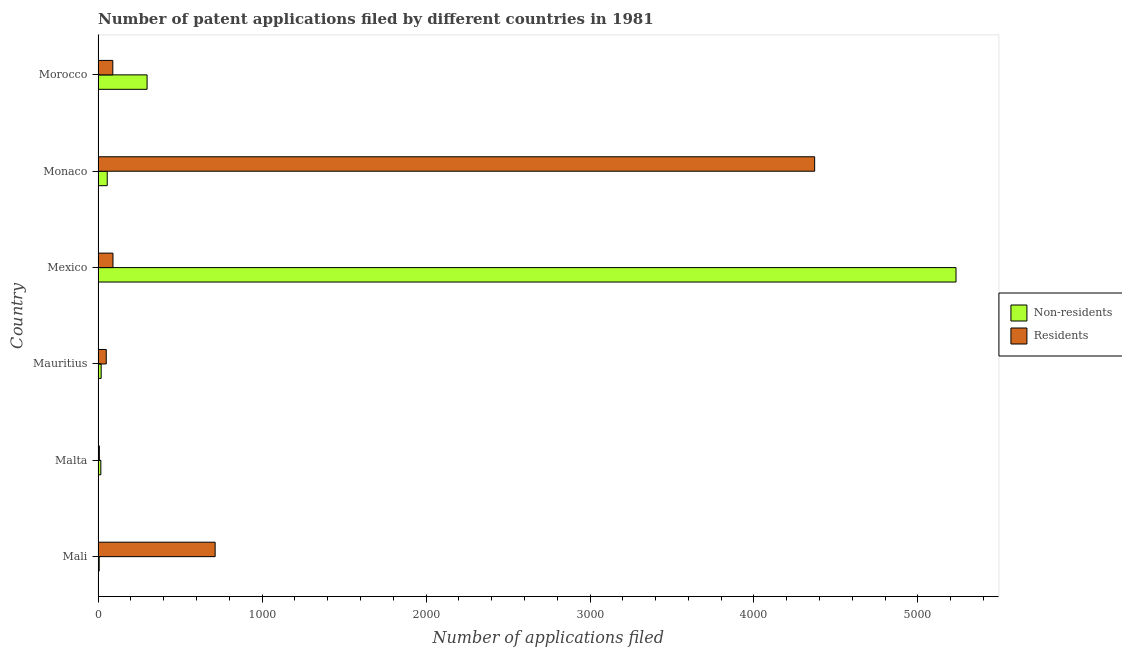How many different coloured bars are there?
Provide a succinct answer. 2. Are the number of bars per tick equal to the number of legend labels?
Offer a terse response. Yes. Are the number of bars on each tick of the Y-axis equal?
Your answer should be very brief. Yes. How many bars are there on the 2nd tick from the top?
Offer a terse response. 2. What is the label of the 1st group of bars from the top?
Offer a very short reply. Morocco. In how many cases, is the number of bars for a given country not equal to the number of legend labels?
Your response must be concise. 0. What is the number of patent applications by non residents in Mali?
Offer a terse response. 7. Across all countries, what is the maximum number of patent applications by non residents?
Your answer should be very brief. 5232. Across all countries, what is the minimum number of patent applications by residents?
Your answer should be compact. 8. In which country was the number of patent applications by residents minimum?
Make the answer very short. Malta. What is the total number of patent applications by residents in the graph?
Keep it short and to the point. 5323. What is the difference between the number of patent applications by residents in Mali and that in Monaco?
Offer a very short reply. -3656. What is the difference between the number of patent applications by residents in Mali and the number of patent applications by non residents in Monaco?
Ensure brevity in your answer.  658. What is the average number of patent applications by residents per country?
Provide a succinct answer. 887.17. What is the difference between the number of patent applications by non residents and number of patent applications by residents in Mexico?
Your answer should be very brief. 5141. What is the ratio of the number of patent applications by non residents in Malta to that in Morocco?
Ensure brevity in your answer.  0.06. Is the number of patent applications by non residents in Mexico less than that in Monaco?
Keep it short and to the point. No. Is the difference between the number of patent applications by residents in Malta and Mauritius greater than the difference between the number of patent applications by non residents in Malta and Mauritius?
Keep it short and to the point. No. What is the difference between the highest and the second highest number of patent applications by residents?
Keep it short and to the point. 3656. What is the difference between the highest and the lowest number of patent applications by residents?
Make the answer very short. 4362. Is the sum of the number of patent applications by residents in Malta and Monaco greater than the maximum number of patent applications by non residents across all countries?
Provide a succinct answer. No. What does the 2nd bar from the top in Mexico represents?
Provide a short and direct response. Non-residents. What does the 2nd bar from the bottom in Malta represents?
Offer a terse response. Residents. How many bars are there?
Ensure brevity in your answer.  12. Are all the bars in the graph horizontal?
Make the answer very short. Yes. What is the difference between two consecutive major ticks on the X-axis?
Ensure brevity in your answer.  1000. Are the values on the major ticks of X-axis written in scientific E-notation?
Keep it short and to the point. No. Does the graph contain any zero values?
Your answer should be very brief. No. Does the graph contain grids?
Offer a terse response. No. Where does the legend appear in the graph?
Your answer should be very brief. Center right. How many legend labels are there?
Provide a short and direct response. 2. What is the title of the graph?
Offer a very short reply. Number of patent applications filed by different countries in 1981. What is the label or title of the X-axis?
Offer a terse response. Number of applications filed. What is the label or title of the Y-axis?
Make the answer very short. Country. What is the Number of applications filed of Residents in Mali?
Your response must be concise. 714. What is the Number of applications filed in Non-residents in Malta?
Ensure brevity in your answer.  17. What is the Number of applications filed in Residents in Malta?
Your response must be concise. 8. What is the Number of applications filed of Residents in Mauritius?
Offer a terse response. 50. What is the Number of applications filed in Non-residents in Mexico?
Make the answer very short. 5232. What is the Number of applications filed in Residents in Mexico?
Provide a succinct answer. 91. What is the Number of applications filed of Non-residents in Monaco?
Offer a very short reply. 56. What is the Number of applications filed of Residents in Monaco?
Your answer should be compact. 4370. What is the Number of applications filed of Non-residents in Morocco?
Offer a terse response. 299. What is the Number of applications filed in Residents in Morocco?
Your response must be concise. 90. Across all countries, what is the maximum Number of applications filed of Non-residents?
Give a very brief answer. 5232. Across all countries, what is the maximum Number of applications filed of Residents?
Ensure brevity in your answer.  4370. What is the total Number of applications filed of Non-residents in the graph?
Provide a succinct answer. 5630. What is the total Number of applications filed in Residents in the graph?
Your answer should be very brief. 5323. What is the difference between the Number of applications filed of Residents in Mali and that in Malta?
Ensure brevity in your answer.  706. What is the difference between the Number of applications filed in Non-residents in Mali and that in Mauritius?
Make the answer very short. -12. What is the difference between the Number of applications filed of Residents in Mali and that in Mauritius?
Offer a terse response. 664. What is the difference between the Number of applications filed of Non-residents in Mali and that in Mexico?
Your answer should be compact. -5225. What is the difference between the Number of applications filed in Residents in Mali and that in Mexico?
Keep it short and to the point. 623. What is the difference between the Number of applications filed of Non-residents in Mali and that in Monaco?
Give a very brief answer. -49. What is the difference between the Number of applications filed of Residents in Mali and that in Monaco?
Your answer should be very brief. -3656. What is the difference between the Number of applications filed of Non-residents in Mali and that in Morocco?
Make the answer very short. -292. What is the difference between the Number of applications filed of Residents in Mali and that in Morocco?
Give a very brief answer. 624. What is the difference between the Number of applications filed in Residents in Malta and that in Mauritius?
Offer a terse response. -42. What is the difference between the Number of applications filed in Non-residents in Malta and that in Mexico?
Offer a terse response. -5215. What is the difference between the Number of applications filed of Residents in Malta and that in Mexico?
Your answer should be very brief. -83. What is the difference between the Number of applications filed in Non-residents in Malta and that in Monaco?
Your response must be concise. -39. What is the difference between the Number of applications filed of Residents in Malta and that in Monaco?
Offer a very short reply. -4362. What is the difference between the Number of applications filed of Non-residents in Malta and that in Morocco?
Ensure brevity in your answer.  -282. What is the difference between the Number of applications filed in Residents in Malta and that in Morocco?
Offer a terse response. -82. What is the difference between the Number of applications filed of Non-residents in Mauritius and that in Mexico?
Keep it short and to the point. -5213. What is the difference between the Number of applications filed in Residents in Mauritius and that in Mexico?
Offer a very short reply. -41. What is the difference between the Number of applications filed of Non-residents in Mauritius and that in Monaco?
Ensure brevity in your answer.  -37. What is the difference between the Number of applications filed in Residents in Mauritius and that in Monaco?
Your answer should be compact. -4320. What is the difference between the Number of applications filed in Non-residents in Mauritius and that in Morocco?
Your answer should be very brief. -280. What is the difference between the Number of applications filed of Residents in Mauritius and that in Morocco?
Ensure brevity in your answer.  -40. What is the difference between the Number of applications filed in Non-residents in Mexico and that in Monaco?
Ensure brevity in your answer.  5176. What is the difference between the Number of applications filed of Residents in Mexico and that in Monaco?
Provide a short and direct response. -4279. What is the difference between the Number of applications filed in Non-residents in Mexico and that in Morocco?
Make the answer very short. 4933. What is the difference between the Number of applications filed of Non-residents in Monaco and that in Morocco?
Offer a terse response. -243. What is the difference between the Number of applications filed in Residents in Monaco and that in Morocco?
Ensure brevity in your answer.  4280. What is the difference between the Number of applications filed in Non-residents in Mali and the Number of applications filed in Residents in Malta?
Provide a succinct answer. -1. What is the difference between the Number of applications filed of Non-residents in Mali and the Number of applications filed of Residents in Mauritius?
Provide a succinct answer. -43. What is the difference between the Number of applications filed of Non-residents in Mali and the Number of applications filed of Residents in Mexico?
Give a very brief answer. -84. What is the difference between the Number of applications filed of Non-residents in Mali and the Number of applications filed of Residents in Monaco?
Ensure brevity in your answer.  -4363. What is the difference between the Number of applications filed in Non-residents in Mali and the Number of applications filed in Residents in Morocco?
Offer a terse response. -83. What is the difference between the Number of applications filed in Non-residents in Malta and the Number of applications filed in Residents in Mauritius?
Offer a terse response. -33. What is the difference between the Number of applications filed of Non-residents in Malta and the Number of applications filed of Residents in Mexico?
Your answer should be very brief. -74. What is the difference between the Number of applications filed of Non-residents in Malta and the Number of applications filed of Residents in Monaco?
Offer a terse response. -4353. What is the difference between the Number of applications filed of Non-residents in Malta and the Number of applications filed of Residents in Morocco?
Provide a succinct answer. -73. What is the difference between the Number of applications filed in Non-residents in Mauritius and the Number of applications filed in Residents in Mexico?
Give a very brief answer. -72. What is the difference between the Number of applications filed of Non-residents in Mauritius and the Number of applications filed of Residents in Monaco?
Offer a very short reply. -4351. What is the difference between the Number of applications filed in Non-residents in Mauritius and the Number of applications filed in Residents in Morocco?
Your answer should be very brief. -71. What is the difference between the Number of applications filed of Non-residents in Mexico and the Number of applications filed of Residents in Monaco?
Offer a very short reply. 862. What is the difference between the Number of applications filed in Non-residents in Mexico and the Number of applications filed in Residents in Morocco?
Give a very brief answer. 5142. What is the difference between the Number of applications filed in Non-residents in Monaco and the Number of applications filed in Residents in Morocco?
Offer a very short reply. -34. What is the average Number of applications filed in Non-residents per country?
Provide a succinct answer. 938.33. What is the average Number of applications filed in Residents per country?
Provide a succinct answer. 887.17. What is the difference between the Number of applications filed in Non-residents and Number of applications filed in Residents in Mali?
Offer a very short reply. -707. What is the difference between the Number of applications filed in Non-residents and Number of applications filed in Residents in Mauritius?
Ensure brevity in your answer.  -31. What is the difference between the Number of applications filed in Non-residents and Number of applications filed in Residents in Mexico?
Offer a terse response. 5141. What is the difference between the Number of applications filed of Non-residents and Number of applications filed of Residents in Monaco?
Provide a short and direct response. -4314. What is the difference between the Number of applications filed of Non-residents and Number of applications filed of Residents in Morocco?
Ensure brevity in your answer.  209. What is the ratio of the Number of applications filed of Non-residents in Mali to that in Malta?
Your answer should be compact. 0.41. What is the ratio of the Number of applications filed of Residents in Mali to that in Malta?
Your answer should be compact. 89.25. What is the ratio of the Number of applications filed of Non-residents in Mali to that in Mauritius?
Your answer should be very brief. 0.37. What is the ratio of the Number of applications filed of Residents in Mali to that in Mauritius?
Offer a terse response. 14.28. What is the ratio of the Number of applications filed of Non-residents in Mali to that in Mexico?
Your answer should be compact. 0. What is the ratio of the Number of applications filed in Residents in Mali to that in Mexico?
Provide a succinct answer. 7.85. What is the ratio of the Number of applications filed in Non-residents in Mali to that in Monaco?
Your answer should be compact. 0.12. What is the ratio of the Number of applications filed of Residents in Mali to that in Monaco?
Make the answer very short. 0.16. What is the ratio of the Number of applications filed of Non-residents in Mali to that in Morocco?
Make the answer very short. 0.02. What is the ratio of the Number of applications filed in Residents in Mali to that in Morocco?
Provide a short and direct response. 7.93. What is the ratio of the Number of applications filed of Non-residents in Malta to that in Mauritius?
Keep it short and to the point. 0.89. What is the ratio of the Number of applications filed in Residents in Malta to that in Mauritius?
Your response must be concise. 0.16. What is the ratio of the Number of applications filed of Non-residents in Malta to that in Mexico?
Ensure brevity in your answer.  0. What is the ratio of the Number of applications filed in Residents in Malta to that in Mexico?
Your response must be concise. 0.09. What is the ratio of the Number of applications filed of Non-residents in Malta to that in Monaco?
Provide a succinct answer. 0.3. What is the ratio of the Number of applications filed in Residents in Malta to that in Monaco?
Your answer should be very brief. 0. What is the ratio of the Number of applications filed of Non-residents in Malta to that in Morocco?
Give a very brief answer. 0.06. What is the ratio of the Number of applications filed of Residents in Malta to that in Morocco?
Provide a short and direct response. 0.09. What is the ratio of the Number of applications filed in Non-residents in Mauritius to that in Mexico?
Ensure brevity in your answer.  0. What is the ratio of the Number of applications filed of Residents in Mauritius to that in Mexico?
Your answer should be compact. 0.55. What is the ratio of the Number of applications filed of Non-residents in Mauritius to that in Monaco?
Your response must be concise. 0.34. What is the ratio of the Number of applications filed in Residents in Mauritius to that in Monaco?
Make the answer very short. 0.01. What is the ratio of the Number of applications filed of Non-residents in Mauritius to that in Morocco?
Give a very brief answer. 0.06. What is the ratio of the Number of applications filed in Residents in Mauritius to that in Morocco?
Offer a terse response. 0.56. What is the ratio of the Number of applications filed in Non-residents in Mexico to that in Monaco?
Offer a very short reply. 93.43. What is the ratio of the Number of applications filed in Residents in Mexico to that in Monaco?
Keep it short and to the point. 0.02. What is the ratio of the Number of applications filed of Non-residents in Mexico to that in Morocco?
Make the answer very short. 17.5. What is the ratio of the Number of applications filed of Residents in Mexico to that in Morocco?
Your answer should be very brief. 1.01. What is the ratio of the Number of applications filed in Non-residents in Monaco to that in Morocco?
Offer a very short reply. 0.19. What is the ratio of the Number of applications filed in Residents in Monaco to that in Morocco?
Give a very brief answer. 48.56. What is the difference between the highest and the second highest Number of applications filed in Non-residents?
Provide a short and direct response. 4933. What is the difference between the highest and the second highest Number of applications filed in Residents?
Your response must be concise. 3656. What is the difference between the highest and the lowest Number of applications filed of Non-residents?
Keep it short and to the point. 5225. What is the difference between the highest and the lowest Number of applications filed of Residents?
Your response must be concise. 4362. 